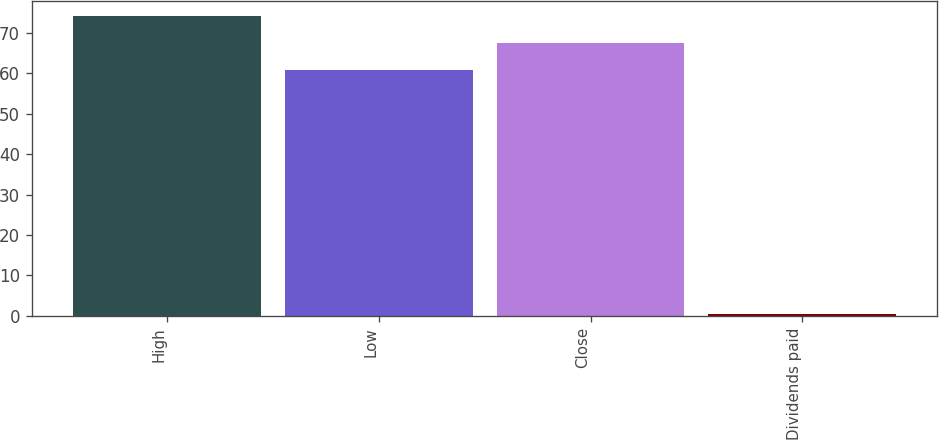Convert chart to OTSL. <chart><loc_0><loc_0><loc_500><loc_500><bar_chart><fcel>High<fcel>Low<fcel>Close<fcel>Dividends paid<nl><fcel>74.31<fcel>60.73<fcel>67.52<fcel>0.32<nl></chart> 